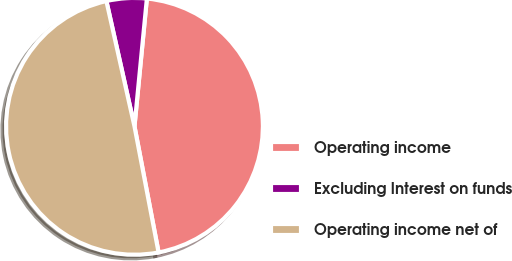Convert chart to OTSL. <chart><loc_0><loc_0><loc_500><loc_500><pie_chart><fcel>Operating income<fcel>Excluding Interest on funds<fcel>Operating income net of<nl><fcel>45.45%<fcel>5.05%<fcel>49.49%<nl></chart> 